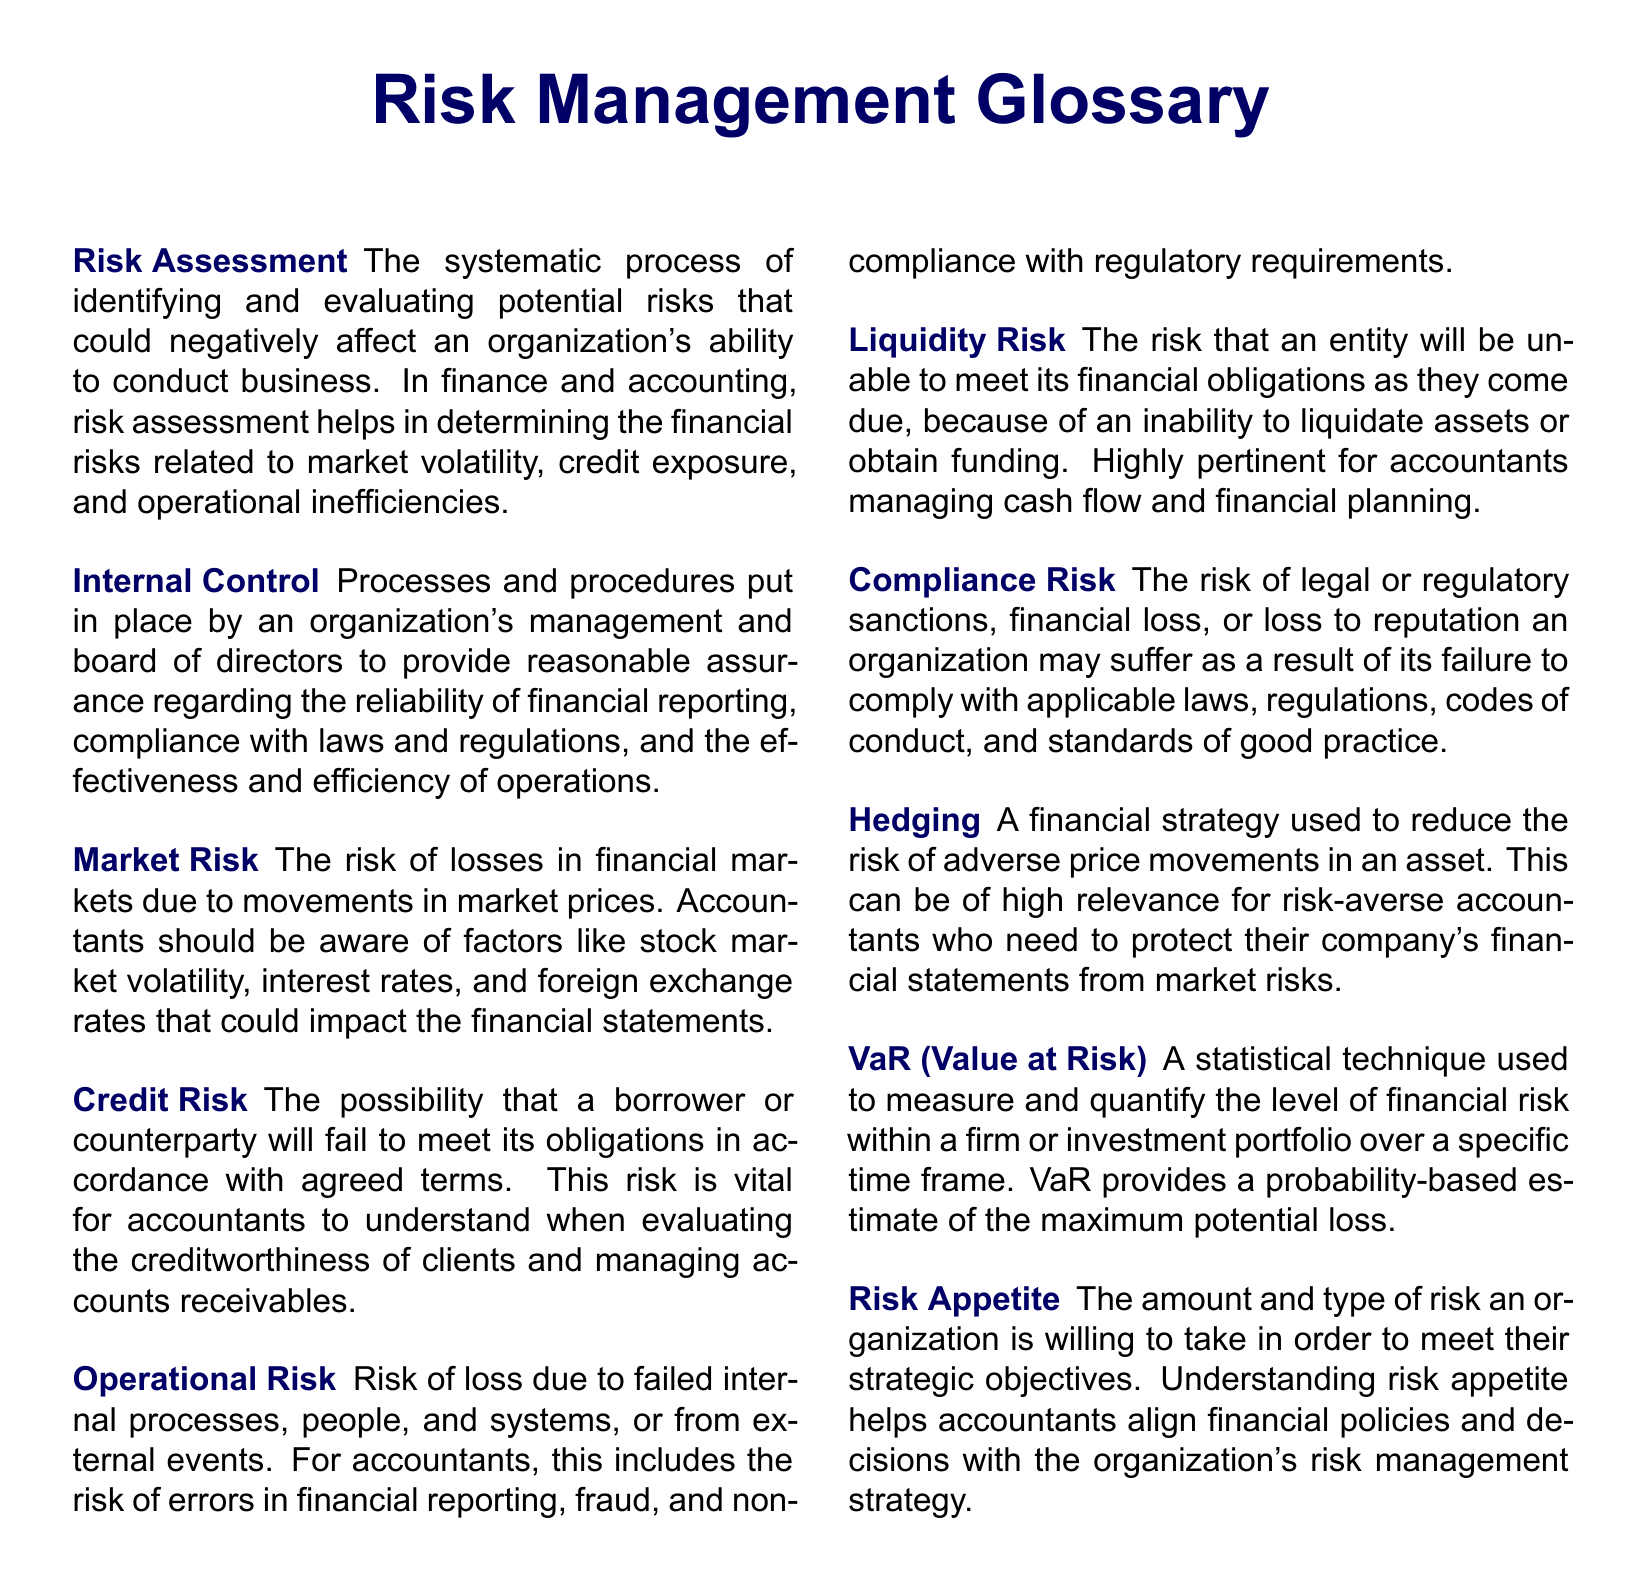What is the definition of Risk Assessment? Risk Assessment is defined as the systematic process of identifying and evaluating potential risks that could negatively affect an organization's ability to conduct business.
Answer: systematic process of identifying and evaluating potential risks What does Liquidity Risk refer to? Liquidity Risk refers to the risk that an entity will be unable to meet its financial obligations as they come due, because of an inability to liquidate assets or obtain funding.
Answer: unable to meet its financial obligations What type of risk is associated with market prices? Market Risk is associated with the risk of losses in financial markets due to movements in market prices.
Answer: Market Risk What financial strategy is used to reduce adverse price movements? The financial strategy used is Hedging, which reduces the risk of adverse price movements in an asset.
Answer: Hedging How does Compliance Risk affect an organization? Compliance Risk affects an organization through legal or regulatory sanctions, financial loss, or loss to reputation due to failure to comply with applicable laws.
Answer: legal or regulatory sanctions What is VaR an acronym for? VaR is an acronym for Value at Risk, a statistical technique used to measure financial risk.
Answer: Value at Risk What is the term for the amount of risk an organization is willing to take? The term for this is Risk Appetite, which refers to the amount and type of risk an organization is willing to take.
Answer: Risk Appetite Which risk is vital for accountants in evaluating creditworthiness? Credit Risk is vital for accountants in evaluating the creditworthiness of clients and managing accounts receivables.
Answer: Credit Risk How does Internal Control contribute to an organization? Internal Control contributes by providing reasonable assurance regarding the reliability of financial reporting and compliance with laws and regulations.
Answer: reasonable assurance regarding reliability of reporting 